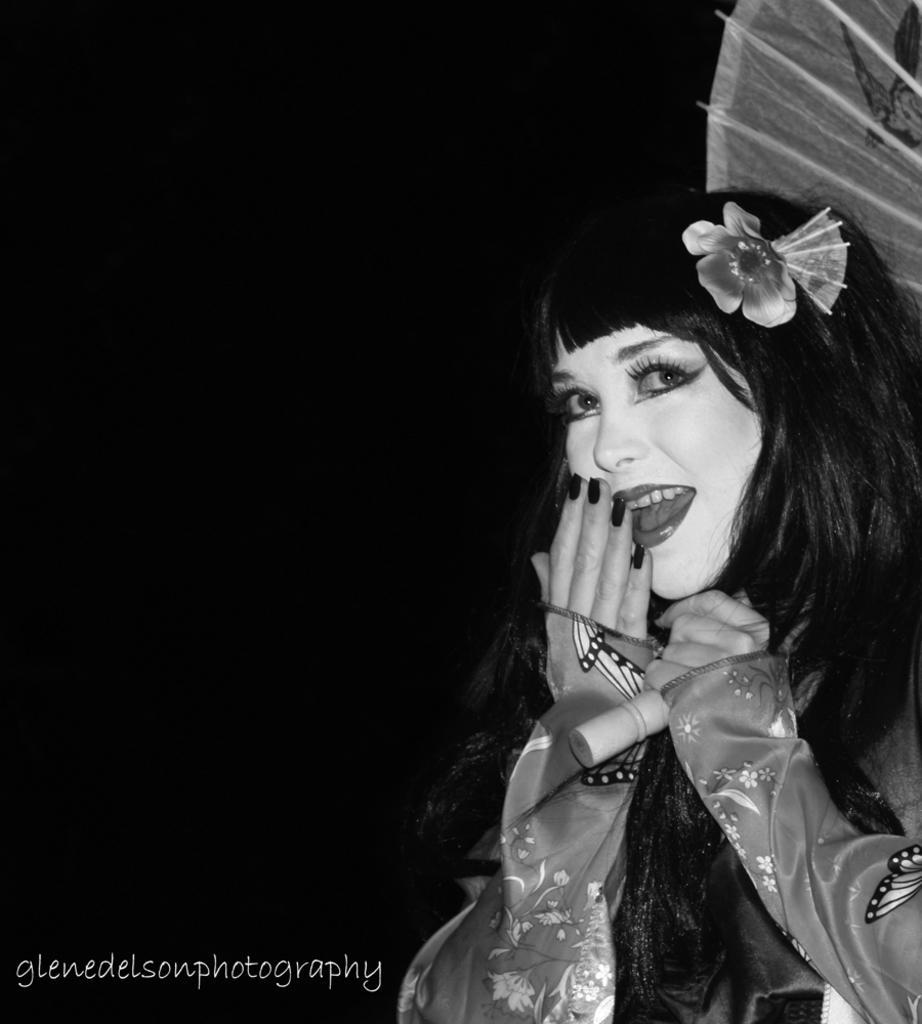Can you describe this image briefly? This is an edited picture. On the right there is a woman in a chinese traditional costume. The background is dark. 